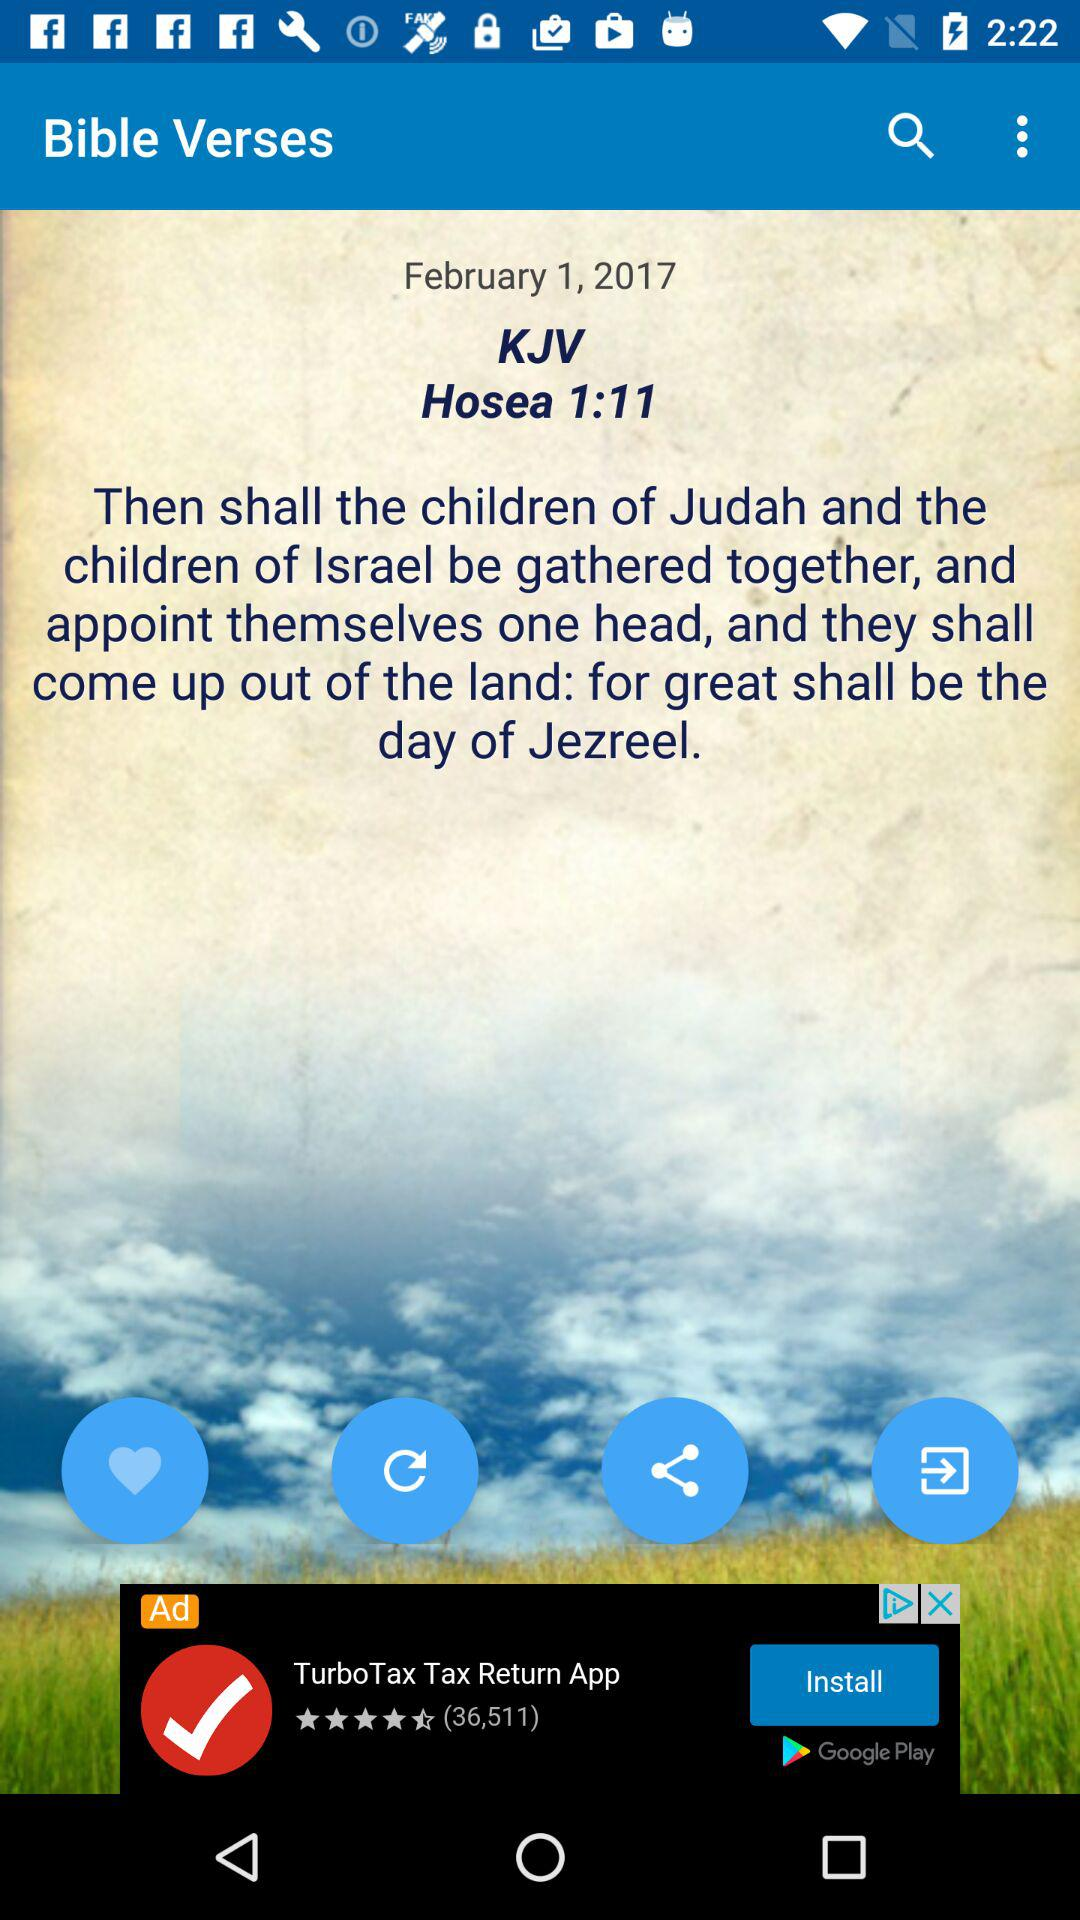What is the date? The date is February 1, 2017. 